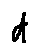<formula> <loc_0><loc_0><loc_500><loc_500>d</formula> 